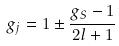Convert formula to latex. <formula><loc_0><loc_0><loc_500><loc_500>g _ { j } = 1 \pm \frac { g _ { S } - 1 } { 2 l + 1 }</formula> 